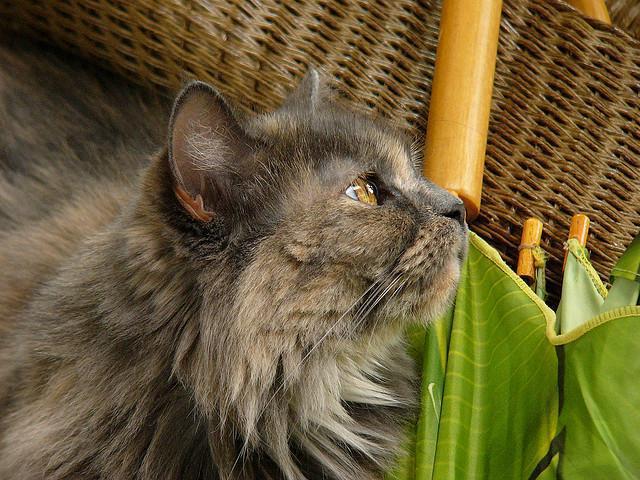How many cats can you see?
Give a very brief answer. 1. How many people are dressed in green?
Give a very brief answer. 0. 